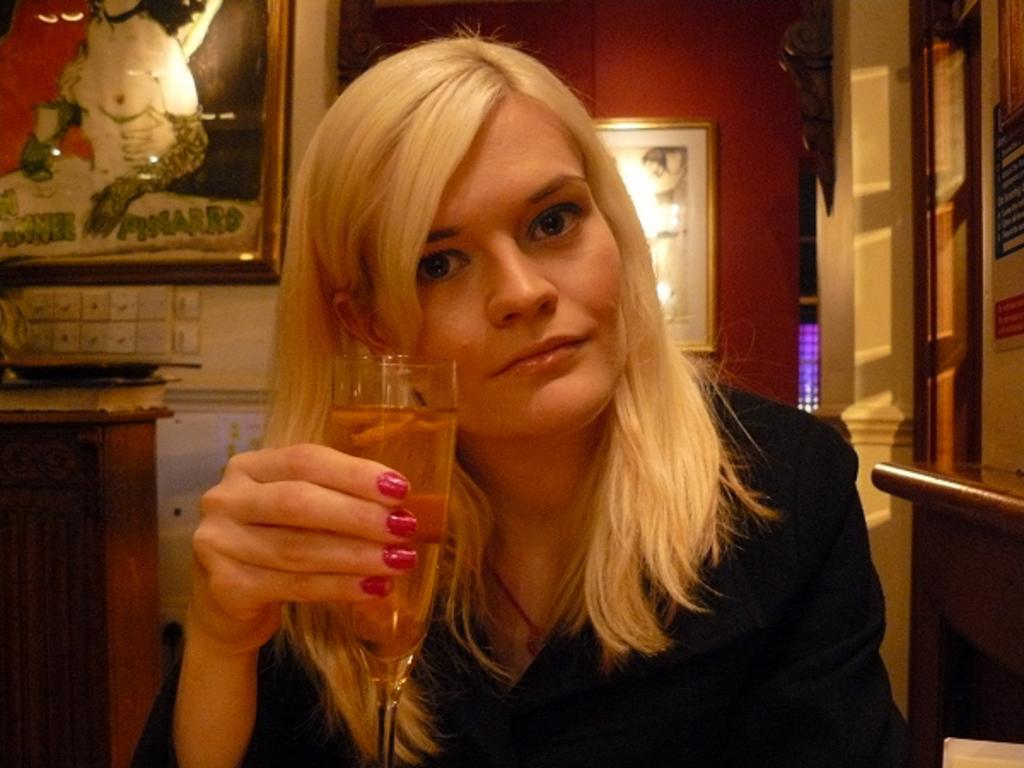In one or two sentences, can you explain what this image depicts? A woman is posing to camera holding a wine glass in her hand. She wears a black color suit. There are some paintings in the background. 